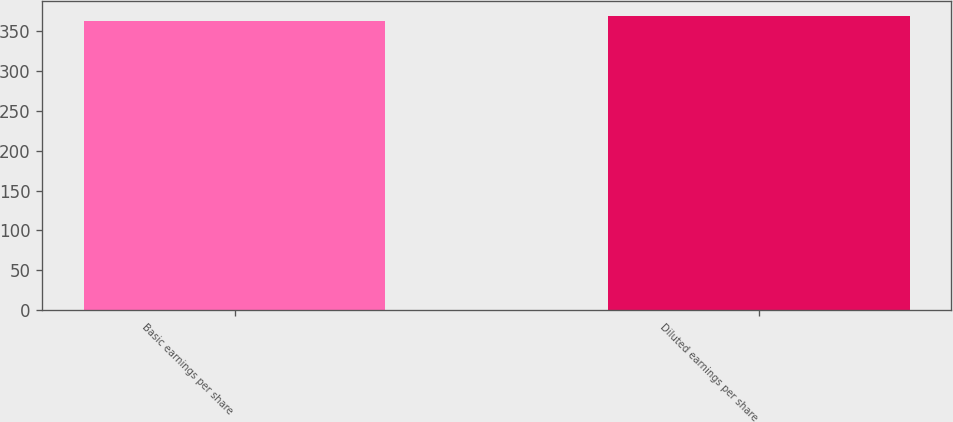Convert chart. <chart><loc_0><loc_0><loc_500><loc_500><bar_chart><fcel>Basic earnings per share<fcel>Diluted earnings per share<nl><fcel>363<fcel>369.2<nl></chart> 